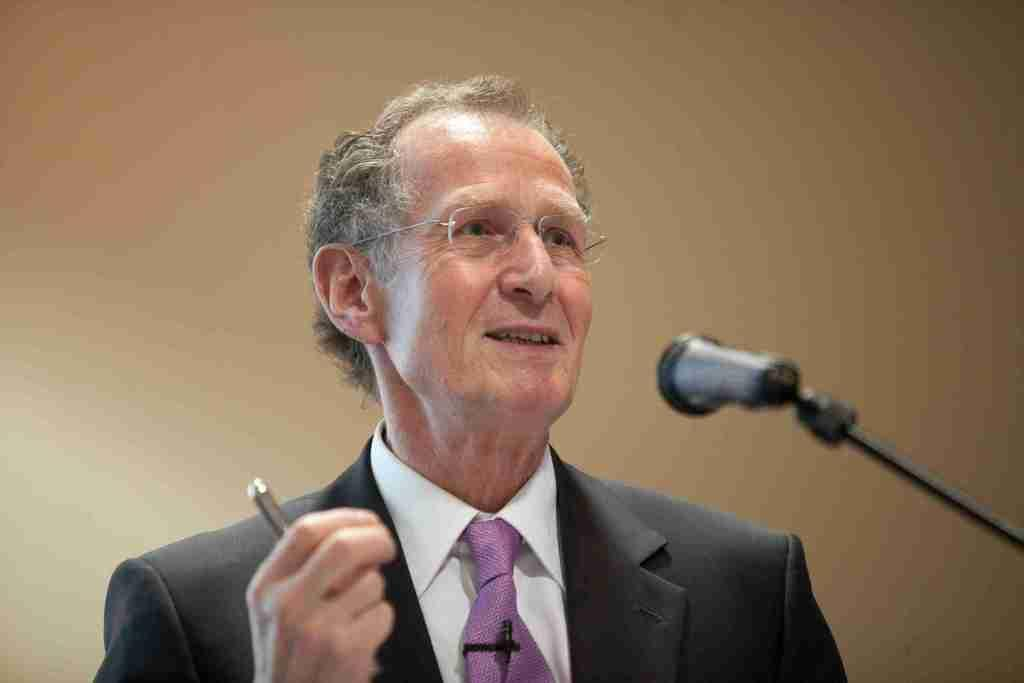What can be seen in the image? There is a person in the image. Can you describe the person's appearance? The person is wearing spectacles. What is the person holding in the image? The person is holding an object. What is in front of the person? There is a microphone (mic) in front of the person. What can be seen in the background of the image? There is a surface visible in the background of the image. What type of office crush can be seen in the image? There is no office crush present in the image. Is there a cracker being eaten by the person in the image? There is no cracker visible in the image. 